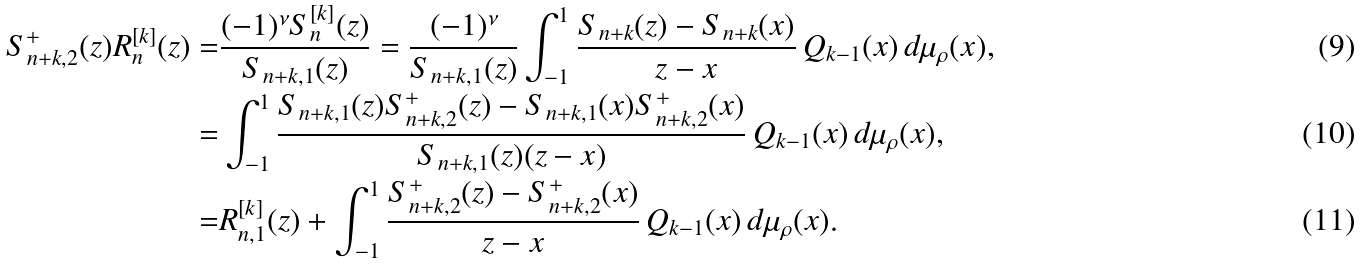<formula> <loc_0><loc_0><loc_500><loc_500>S ^ { + } _ { n + k , 2 } ( z ) R ^ { [ k ] } _ { n } ( z ) = & \frac { { ( - 1 ) ^ { \nu } } S ^ { [ k ] } _ { n } ( z ) } { S _ { n + k , 1 } ( z ) } = \frac { { ( - 1 ) ^ { \nu } } } { S _ { n + k , 1 } ( z ) } \int _ { - 1 } ^ { 1 } \frac { S _ { n + k } ( z ) - S _ { n + k } ( x ) } { z - x } \, Q _ { k - 1 } ( x ) \, d \mu _ { \rho } ( x ) , \\ = & \int _ { - 1 } ^ { 1 } \frac { S _ { n + k , 1 } ( z ) S ^ { + } _ { n + k , 2 } ( z ) - S _ { n + k , 1 } ( x ) S ^ { + } _ { n + k , 2 } ( x ) } { S _ { n + k , 1 } ( z ) ( z - x ) } \, Q _ { k - 1 } ( x ) \, d \mu _ { \rho } ( x ) , \\ = & R ^ { [ k ] } _ { n , 1 } ( z ) + \int _ { - 1 } ^ { 1 } \frac { S ^ { + } _ { n + k , 2 } ( z ) - S ^ { + } _ { n + k , 2 } ( x ) } { z - x } \, Q _ { k - 1 } ( x ) \, d \mu _ { \rho } ( x ) .</formula> 